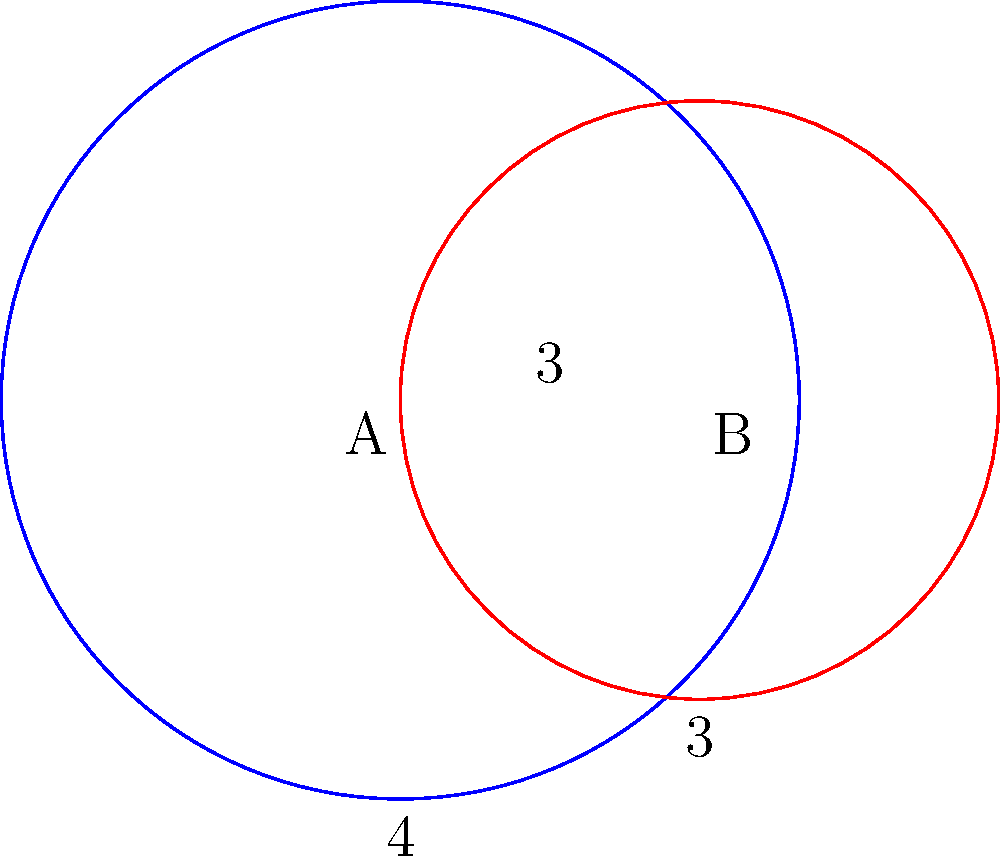Two cultural spheres of influence are represented by overlapping circles in the diagram. Circle A has a radius of 4 units, and circle B has a radius of 3 units. The centers of the circles are 3 units apart. Calculate the area of the overlapping region (shaded area) to determine the extent of cultural interaction. Round your answer to two decimal places. To find the area of the overlapping region, we'll use the formula for the area of intersection of two circles:

1) First, calculate the distance $d$ between the centers:
   $d = 3$ (given in the problem)

2) Use the formula for the area of intersection:
   $A = r_1^2 \arccos(\frac{d^2 + r_1^2 - r_2^2}{2dr_1}) + r_2^2 \arccos(\frac{d^2 + r_2^2 - r_1^2}{2dr_2}) - \frac{1}{2}\sqrt{(-d+r_1+r_2)(d+r_1-r_2)(d-r_1+r_2)(d+r_1+r_2)}$

   Where $r_1 = 4$ and $r_2 = 3$

3) Substitute the values:
   $A = 4^2 \arccos(\frac{3^2 + 4^2 - 3^2}{2 \cdot 3 \cdot 4}) + 3^2 \arccos(\frac{3^2 + 3^2 - 4^2}{2 \cdot 3 \cdot 3}) - \frac{1}{2}\sqrt{(-3+4+3)(3+4-3)(3-4+3)(3+4+3)}$

4) Simplify:
   $A = 16 \arccos(\frac{25}{24}) + 9 \arccos(\frac{10}{18}) - \frac{1}{2}\sqrt{4 \cdot 4 \cdot 2 \cdot 10}$

5) Calculate:
   $A \approx 16 \cdot 0.2934 + 9 \cdot 1.0742 - \frac{1}{2}\sqrt{320}$
   $A \approx 4.6944 + 9.6678 - 8.9443$
   $A \approx 5.4179$

6) Round to two decimal places:
   $A \approx 5.42$ square units
Answer: 5.42 square units 